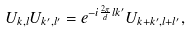Convert formula to latex. <formula><loc_0><loc_0><loc_500><loc_500>U _ { k , l } U _ { k ^ { \prime } , l ^ { \prime } } = e ^ { - i \frac { 2 \pi } { d } l k ^ { \prime } } U _ { k + k ^ { \prime } , l + l ^ { \prime } } ,</formula> 